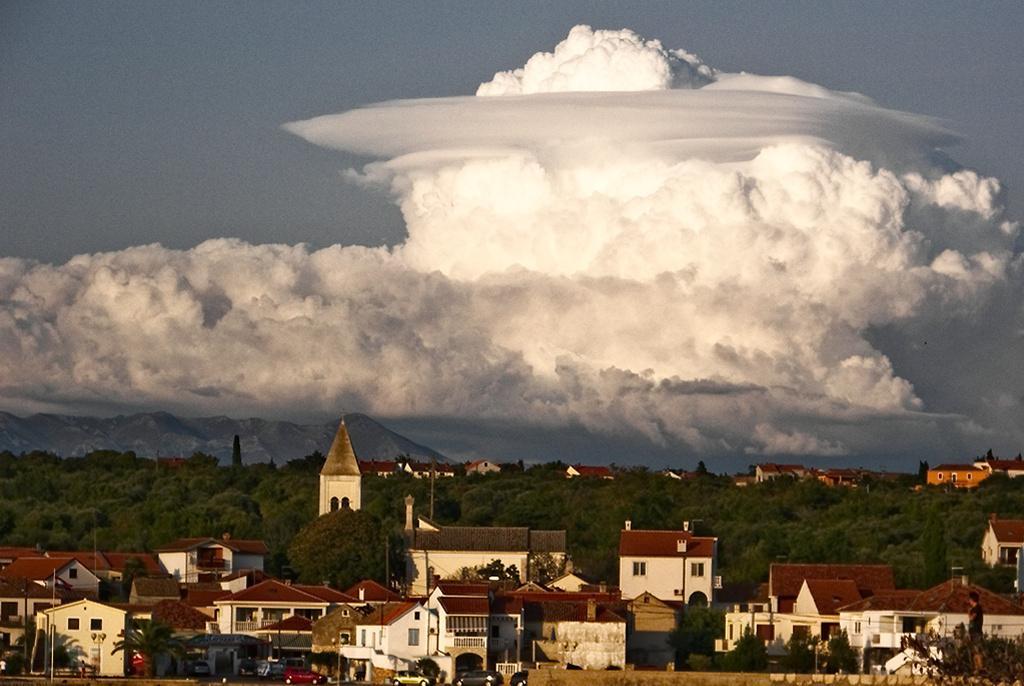Describe this image in one or two sentences. In this image I can see buildings. There are vehicles, trees, poles, mountains and there is a person. In the background there is sky. 